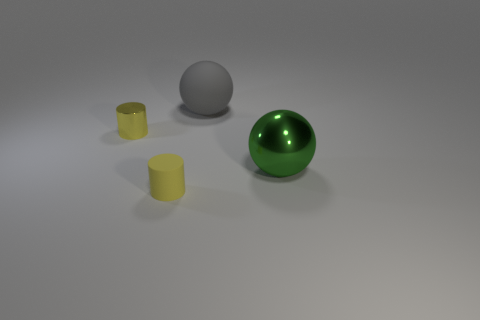Add 4 tiny brown matte cylinders. How many objects exist? 8 Add 1 large gray rubber objects. How many large gray rubber objects exist? 2 Subtract 1 green spheres. How many objects are left? 3 Subtract all yellow rubber cylinders. Subtract all big metal balls. How many objects are left? 2 Add 4 gray rubber things. How many gray rubber things are left? 5 